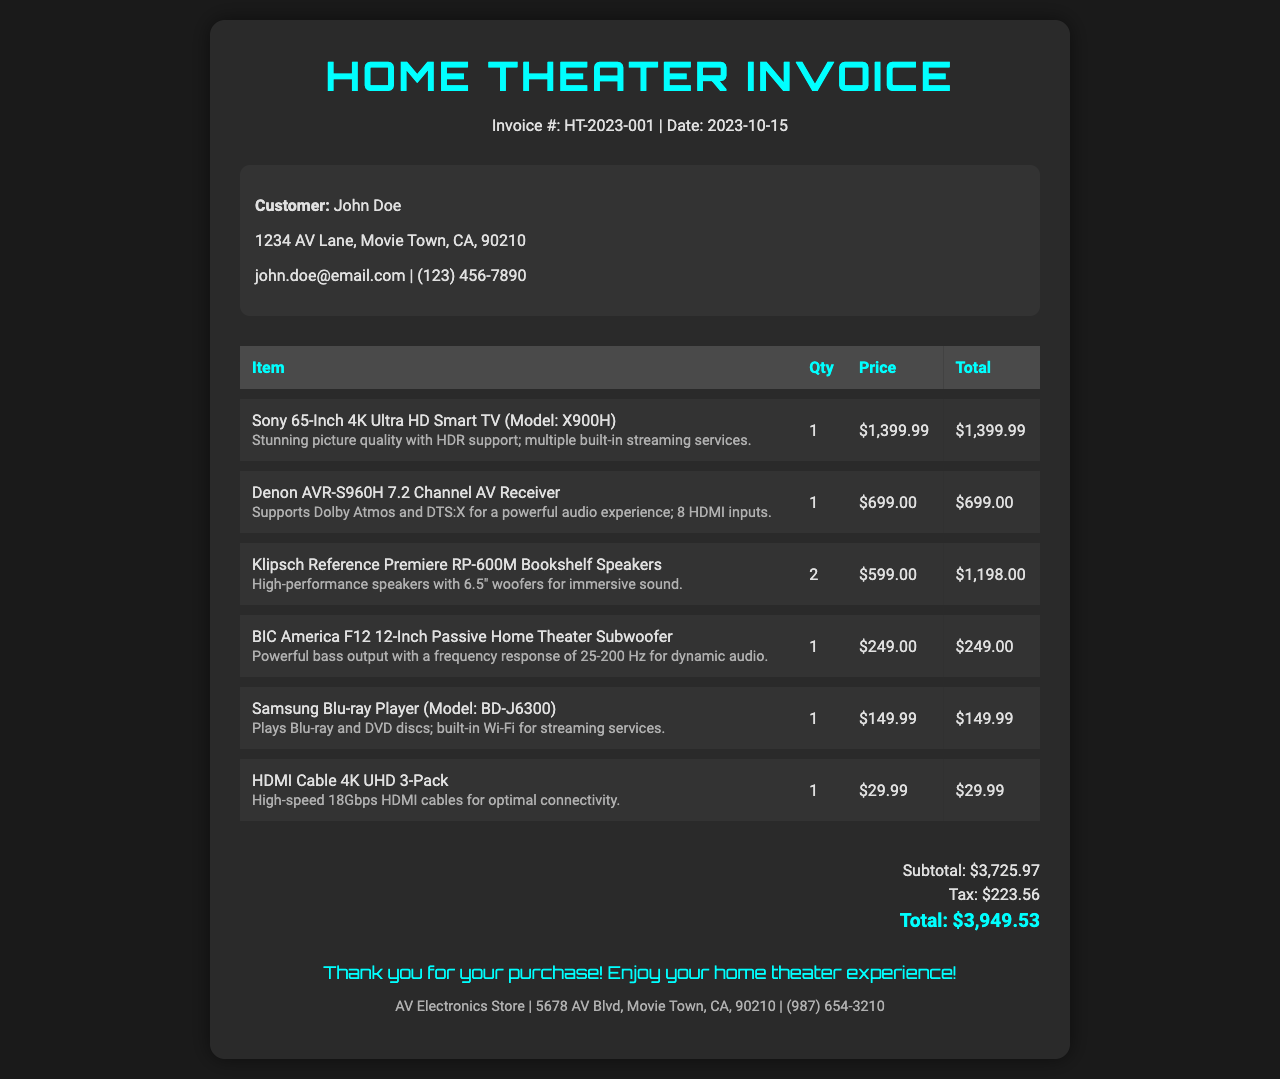What is the invoice number? The invoice number is listed at the top of the document, which is HT-2023-001.
Answer: HT-2023-001 Who is the customer? The customer details can be found in the customer information section. The customer's name is mentioned as John Doe.
Answer: John Doe What is the total price of the speakers? The total price of the speakers can be calculated from the invoice where it lists the Klipsch Reference Premiere RP-600M Bookshelf Speakers with a total of $1,198.00.
Answer: $1,198.00 How many HDMI cables were purchased? The quantity of HDMI cables is detailed in the invoice under the corresponding item. It shows that 1 pack was purchased.
Answer: 1 What is the subtotal amount? The subtotal is the total of all items before tax, mentioned in the summary section of the invoice.
Answer: $3,725.97 What tax amount was applied? The invoice specifies the tax amount in the summary section as $223.56.
Answer: $223.56 What model is the Blu-ray player? The model of the Blu-ray player is included in the description, which can be found in the item list. It is BD-J6300.
Answer: BD-J6300 What is the date of the invoice? The date of the invoice is stated at the top of the document next to the invoice number.
Answer: 2023-10-15 What store issued this invoice? The store information is located in the footer of the document, which includes the store name AV Electronics Store.
Answer: AV Electronics Store 